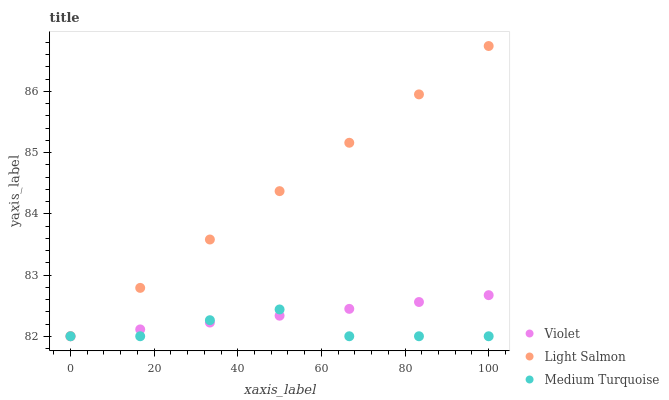Does Medium Turquoise have the minimum area under the curve?
Answer yes or no. Yes. Does Light Salmon have the maximum area under the curve?
Answer yes or no. Yes. Does Violet have the minimum area under the curve?
Answer yes or no. No. Does Violet have the maximum area under the curve?
Answer yes or no. No. Is Light Salmon the smoothest?
Answer yes or no. Yes. Is Medium Turquoise the roughest?
Answer yes or no. Yes. Is Violet the smoothest?
Answer yes or no. No. Is Violet the roughest?
Answer yes or no. No. Does Light Salmon have the lowest value?
Answer yes or no. Yes. Does Light Salmon have the highest value?
Answer yes or no. Yes. Does Violet have the highest value?
Answer yes or no. No. Does Violet intersect Light Salmon?
Answer yes or no. Yes. Is Violet less than Light Salmon?
Answer yes or no. No. Is Violet greater than Light Salmon?
Answer yes or no. No. 